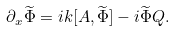Convert formula to latex. <formula><loc_0><loc_0><loc_500><loc_500>\partial _ { x } \widetilde { \Phi } = i k [ A , \widetilde { \Phi } ] - i \widetilde { \Phi } Q .</formula> 